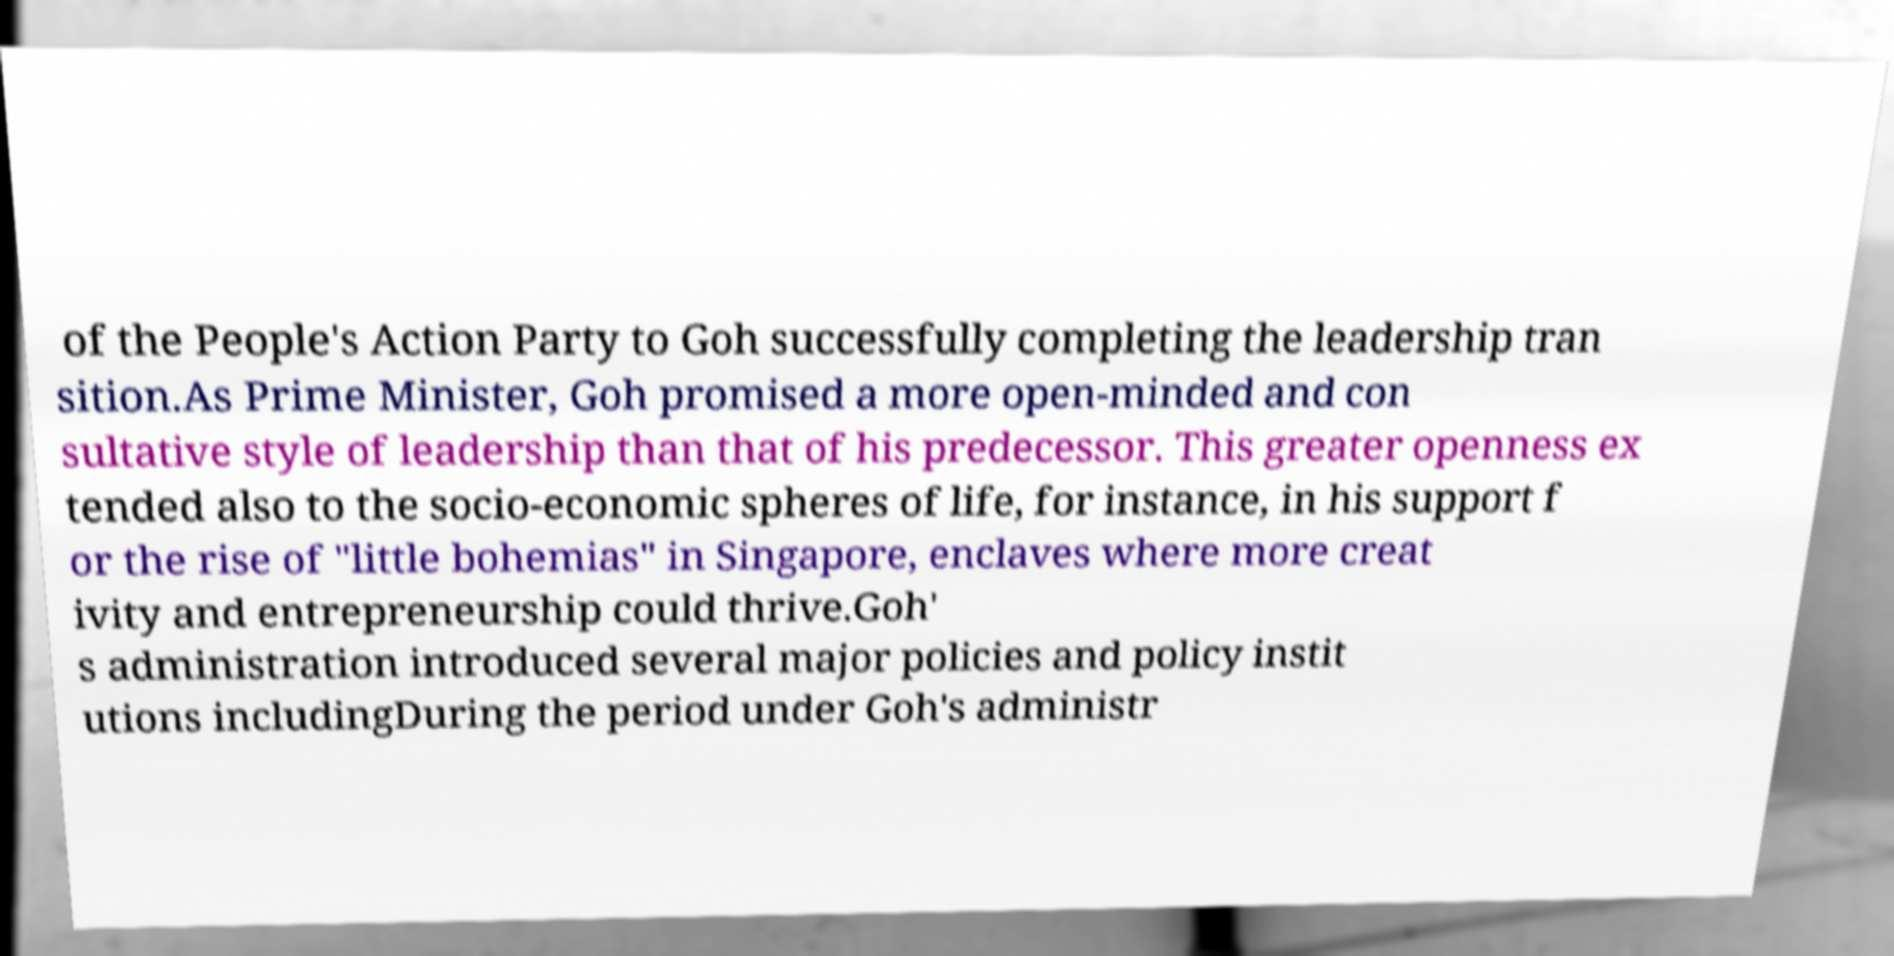Can you accurately transcribe the text from the provided image for me? of the People's Action Party to Goh successfully completing the leadership tran sition.As Prime Minister, Goh promised a more open-minded and con sultative style of leadership than that of his predecessor. This greater openness ex tended also to the socio-economic spheres of life, for instance, in his support f or the rise of "little bohemias" in Singapore, enclaves where more creat ivity and entrepreneurship could thrive.Goh' s administration introduced several major policies and policy instit utions includingDuring the period under Goh's administr 